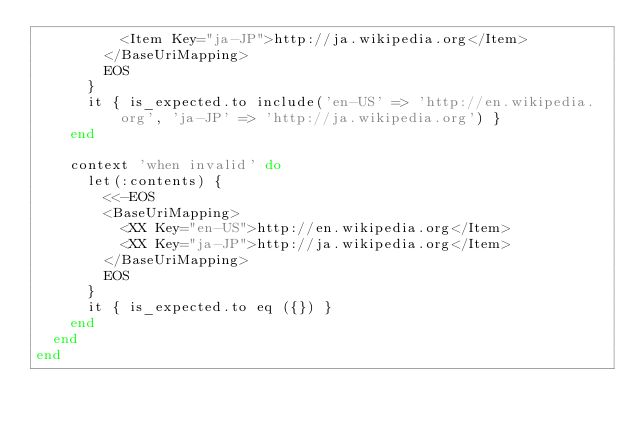<code> <loc_0><loc_0><loc_500><loc_500><_Ruby_>          <Item Key="ja-JP">http://ja.wikipedia.org</Item>
        </BaseUriMapping>
        EOS
      }
      it { is_expected.to include('en-US' => 'http://en.wikipedia.org', 'ja-JP' => 'http://ja.wikipedia.org') }
    end

    context 'when invalid' do
      let(:contents) {
        <<-EOS
        <BaseUriMapping>
          <XX Key="en-US">http://en.wikipedia.org</Item>
          <XX Key="ja-JP">http://ja.wikipedia.org</Item>
        </BaseUriMapping>
        EOS
      }
      it { is_expected.to eq ({}) }
    end
  end
end</code> 